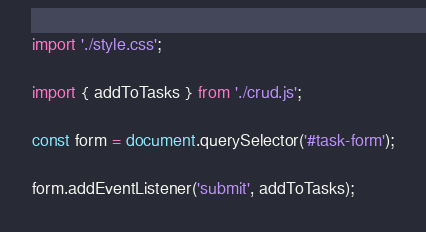<code> <loc_0><loc_0><loc_500><loc_500><_JavaScript_>import './style.css';

import { addToTasks } from './crud.js';

const form = document.querySelector('#task-form');

form.addEventListener('submit', addToTasks);
</code> 